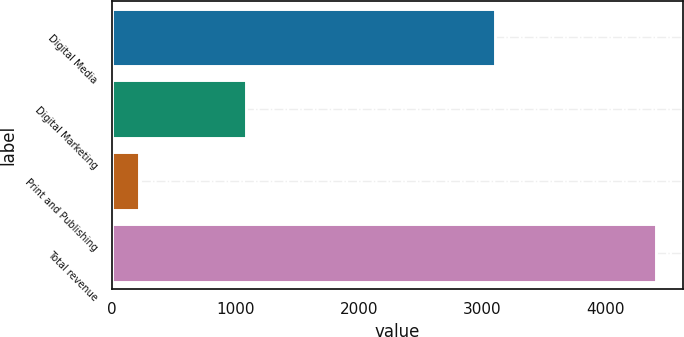Convert chart. <chart><loc_0><loc_0><loc_500><loc_500><bar_chart><fcel>Digital Media<fcel>Digital Marketing<fcel>Print and Publishing<fcel>Total revenue<nl><fcel>3101.9<fcel>1085<fcel>216.8<fcel>4403.7<nl></chart> 